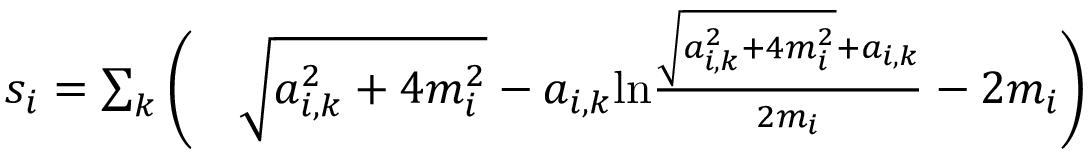Convert formula to latex. <formula><loc_0><loc_0><loc_500><loc_500>\begin{array} { r l } { s _ { i } = \sum _ { k } \left ( } & \sqrt { a _ { i , k } ^ { 2 } + 4 m _ { i } ^ { 2 } } - a _ { i , k } \ln \frac { \sqrt { a _ { i , k } ^ { 2 } + 4 m _ { i } ^ { 2 } } + a _ { i , k } } { 2 m _ { i } } - 2 m _ { i } \right ) } \end{array}</formula> 